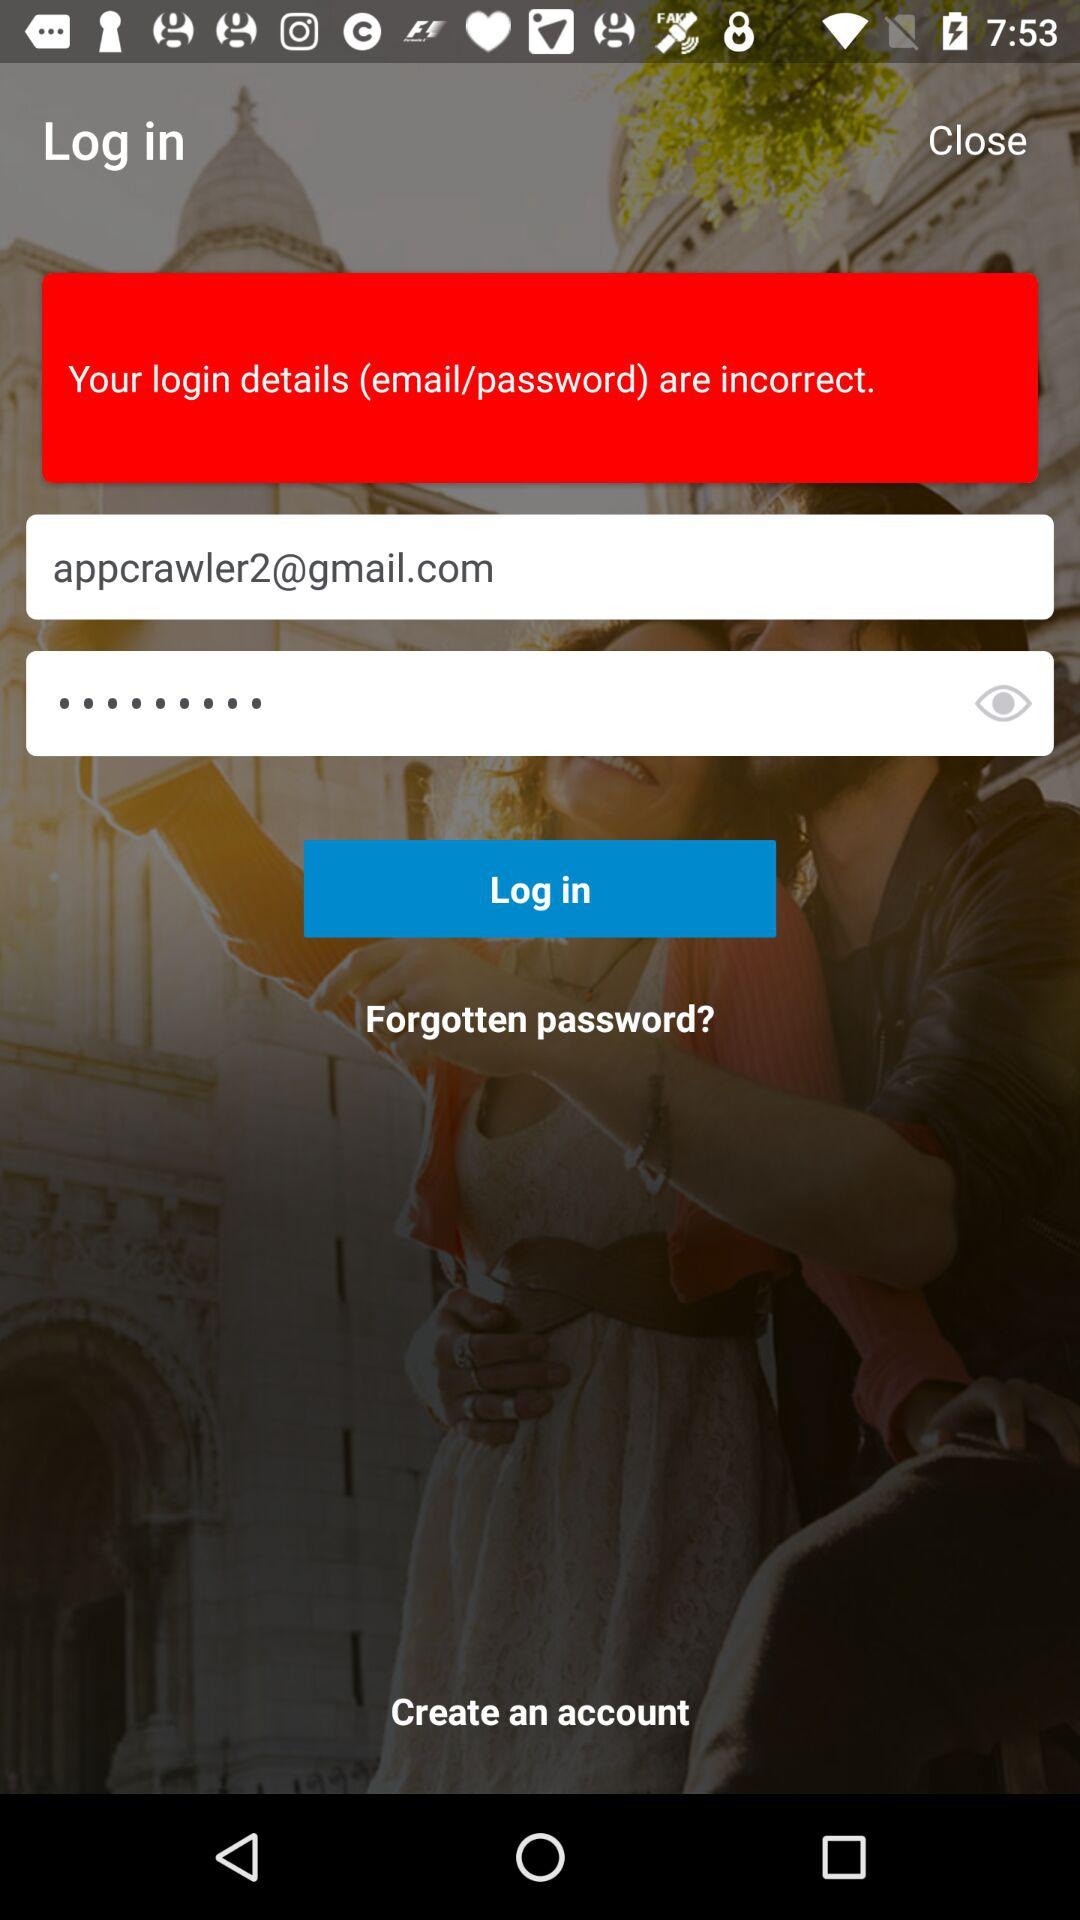What is the email address of the user? The email address of the user is appcrawler2@gmail.com. 